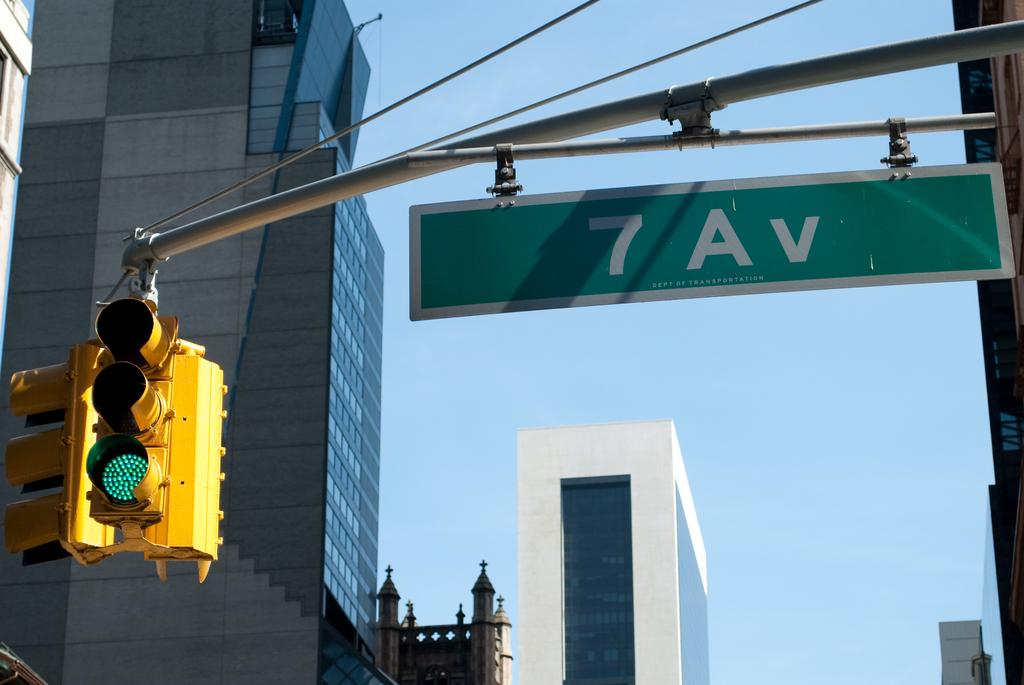<image>
Relay a brief, clear account of the picture shown. A sign for 7 Ave can be seen next to a yellow stoplight and tall buildings 